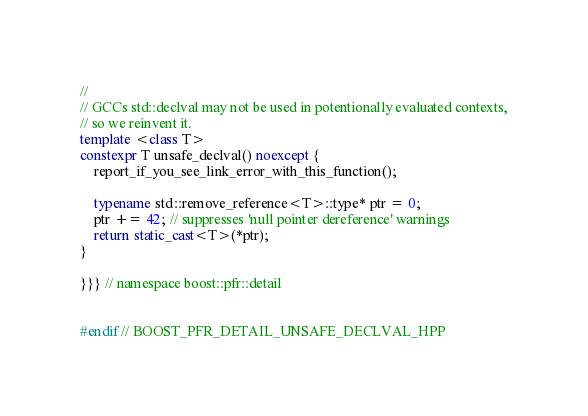<code> <loc_0><loc_0><loc_500><loc_500><_C++_>//
// GCCs std::declval may not be used in potentionally evaluated contexts,
// so we reinvent it.
template <class T>
constexpr T unsafe_declval() noexcept {
    report_if_you_see_link_error_with_this_function();

    typename std::remove_reference<T>::type* ptr = 0;
    ptr += 42; // suppresses 'null pointer dereference' warnings
    return static_cast<T>(*ptr);
}

}}} // namespace boost::pfr::detail


#endif // BOOST_PFR_DETAIL_UNSAFE_DECLVAL_HPP

</code> 